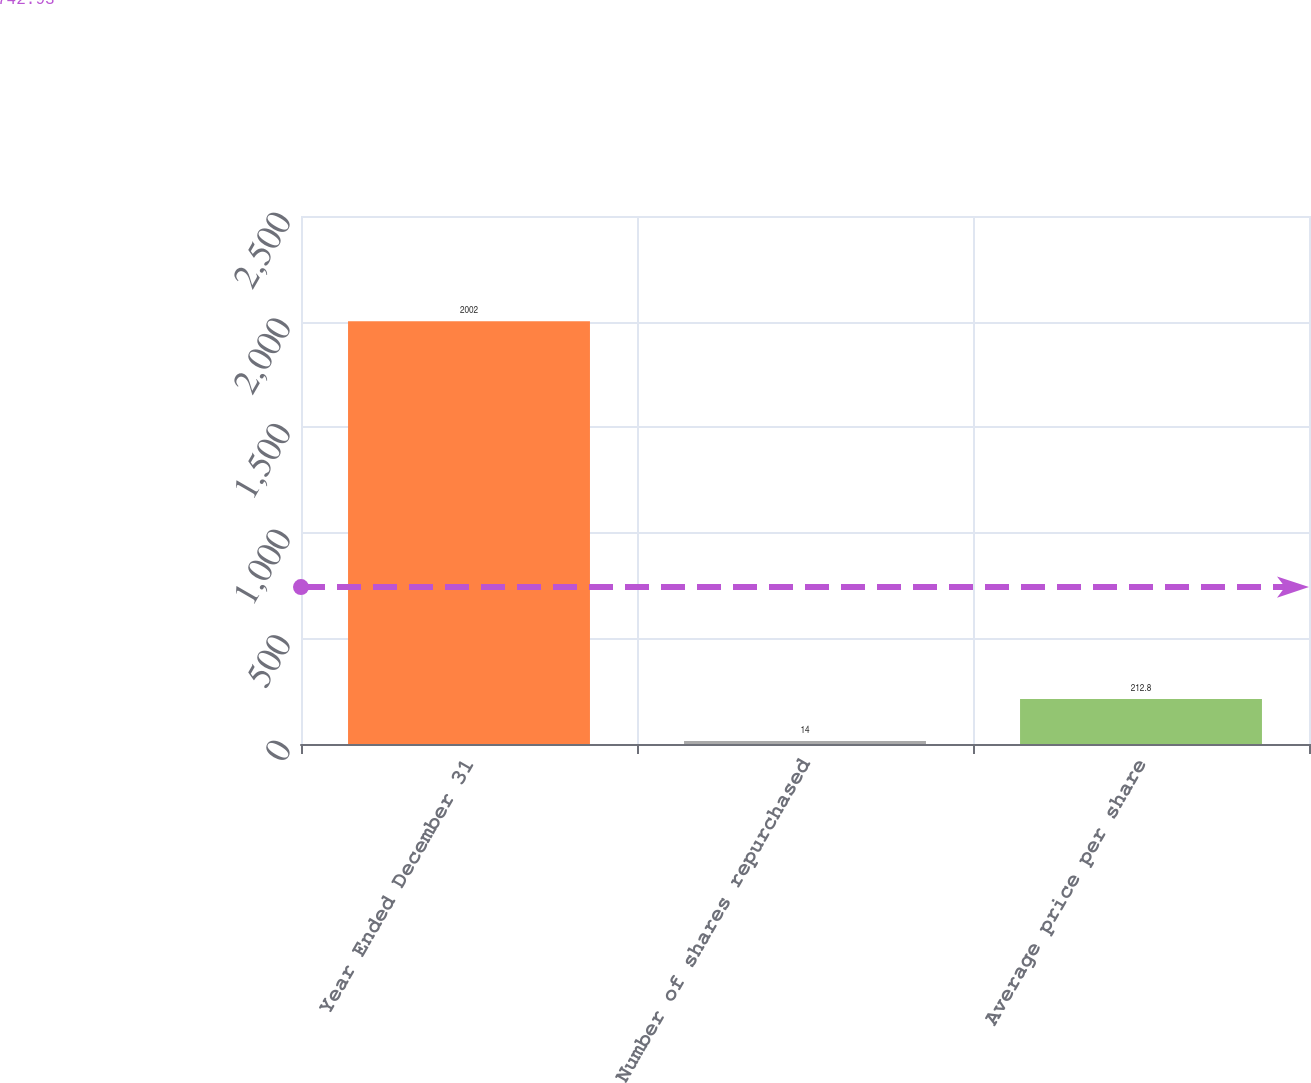Convert chart to OTSL. <chart><loc_0><loc_0><loc_500><loc_500><bar_chart><fcel>Year Ended December 31<fcel>Number of shares repurchased<fcel>Average price per share<nl><fcel>2002<fcel>14<fcel>212.8<nl></chart> 